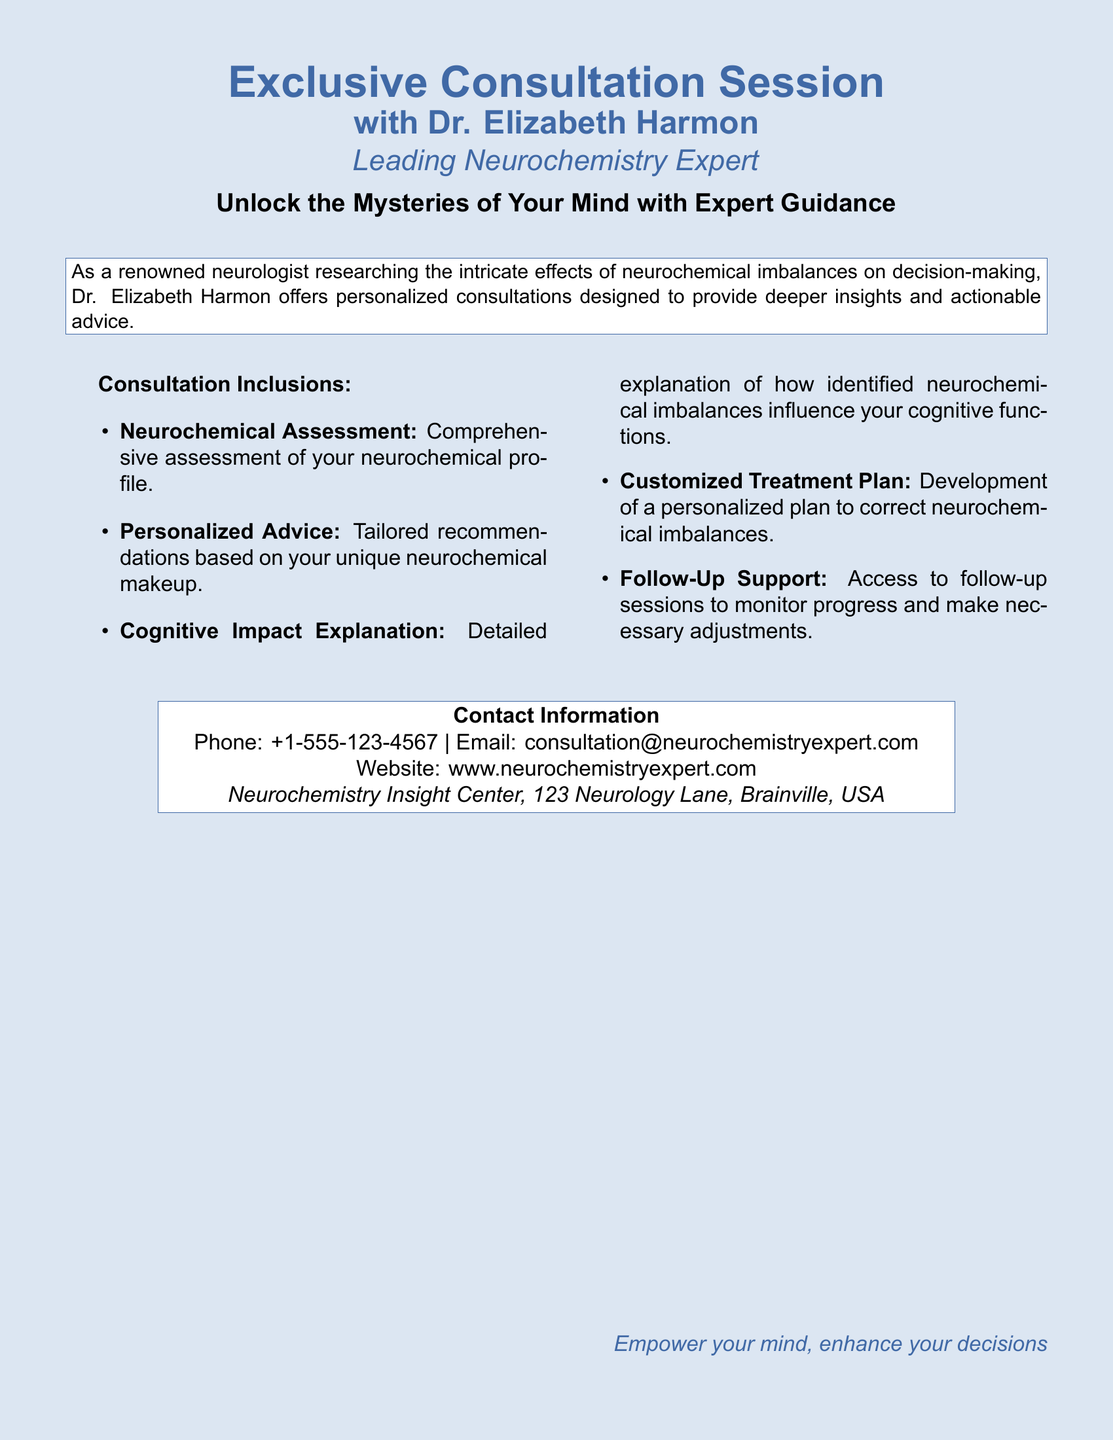What is the name of the expert? The document specifically mentions the leading expert as Dr. Elizabeth Harmon.
Answer: Dr. Elizabeth Harmon What is the primary focus of the consultation? The consultation aims to provide personalized advice on neurochemical imbalances and their impact on cognitive processes.
Answer: Personalized advice on neurochemical imbalances What is included in the neurochemical assessment? The document states a comprehensive assessment of your neurochemical profile is included in the consultation.
Answer: Comprehensive assessment What type of support is available after the consultation? Follow-up support is mentioned as part of the consultation inclusions to monitor progress.
Answer: Follow-Up Support What is the contact email provided in the document? The email for contacting the Neurochemistry Insight Center is specified in the contact information section.
Answer: consultation@neurochemistryexpert.com What will be developed during the consultation? The document states that a customized treatment plan will be developed based on the assessment and recommendations.
Answer: Customized Treatment Plan How many items are listed under consultation inclusions? The document enumerates five items that are included in the consultation, including neurochemical assessment and follow-up support.
Answer: Five items Where is the Neurochemistry Insight Center located? The document provides a specific address for the center, which includes Neurology Lane and Brainville.
Answer: 123 Neurology Lane, Brainville, USA 